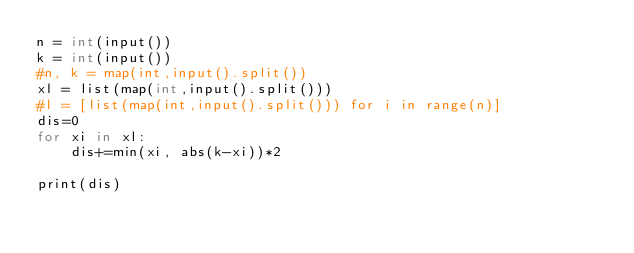<code> <loc_0><loc_0><loc_500><loc_500><_Cython_>n = int(input())
k = int(input())
#n, k = map(int,input().split())
xl = list(map(int,input().split()))
#l = [list(map(int,input().split())) for i in range(n)]
dis=0
for xi in xl:
    dis+=min(xi, abs(k-xi))*2

print(dis)
</code> 